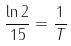<formula> <loc_0><loc_0><loc_500><loc_500>\frac { \ln 2 } { 1 5 } = \frac { 1 } { T }</formula> 